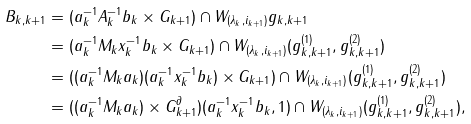Convert formula to latex. <formula><loc_0><loc_0><loc_500><loc_500>B _ { k , k + 1 } & = ( a _ { k } ^ { - 1 } A _ { k } ^ { - 1 } b _ { k } \times G _ { k + 1 } ) \cap W _ { ( \lambda _ { k } , i _ { k + 1 } ) } g _ { k , k + 1 } \\ & = ( a _ { k } ^ { - 1 } M _ { k } x _ { k } ^ { - 1 } b _ { k } \times G _ { k + 1 } ) \cap W _ { ( \lambda _ { k } , i _ { k + 1 } ) } ( g _ { k , k + 1 } ^ { ( 1 ) } , g _ { k , k + 1 } ^ { ( 2 ) } ) \\ & = ( ( a _ { k } ^ { - 1 } M _ { k } a _ { k } ) ( a _ { k } ^ { - 1 } x _ { k } ^ { - 1 } b _ { k } ) \times G _ { k + 1 } ) \cap W _ { ( \lambda _ { k } , i _ { k + 1 } ) } ( g _ { k , k + 1 } ^ { ( 1 ) } , g _ { k , k + 1 } ^ { ( 2 ) } ) \\ & = ( ( a _ { k } ^ { - 1 } M _ { k } a _ { k } ) \times G _ { k + 1 } ^ { \partial } ) ( a _ { k } ^ { - 1 } x _ { k } ^ { - 1 } b _ { k } , 1 ) \cap W _ { ( \lambda _ { k } , i _ { k + 1 } ) } ( g _ { k , k + 1 } ^ { ( 1 ) } , g _ { k , k + 1 } ^ { ( 2 ) } ) ,</formula> 